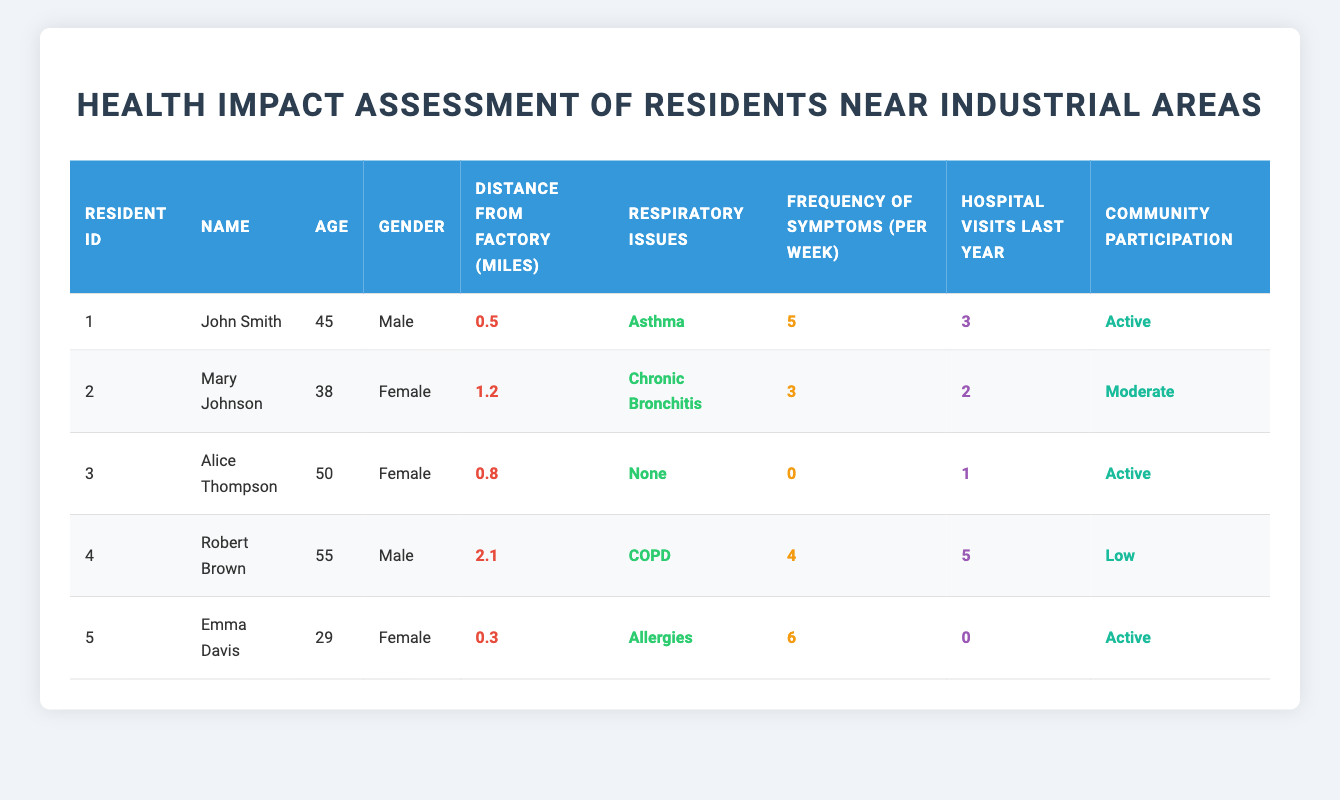What is the respiratory issue reported by John Smith? John Smith's respiratory issue is listed directly in the table under his name, which shows he has asthma.
Answer: Asthma How many hospital visits did Robert Brown have last year? The table states that Robert Brown had 5 hospital visits last year, as shown in the "Hospital Visits Last Year" column.
Answer: 5 How many residents have respiratory issues classified as "None"? The table shows Alice Thompson has "None" listed under respiratory issues, making the count 1.
Answer: 1 What is the average frequency of symptoms among residents with respiratory issues? The frequency of symptoms is as follows: John Smith (5), Mary Johnson (3), Robert Brown (4), and Emma Davis (6). Adding these gives 5 + 3 + 4 + 6 = 18. There are 4 residents with respiratory issues, so the average is 18 / 4 = 4.5.
Answer: 4.5 Is there any resident who had no hospital visits last year? Examining the "Hospital Visits Last Year" column, Emma Davis has 0 visits, indicating a "yes" answer to this question.
Answer: Yes What is the median age of residents with respiratory issues? The ages of residents with respiratory issues (John Smith, Mary Johnson, Robert Brown, Emma Davis) are 45, 38, 55, and 29. Sorting these ages gives us 29, 38, 45, and 55. The median age is the average of the middle two values (38 and 45), which is (38 + 45) / 2 = 41.5.
Answer: 41.5 How many residents live within 1 mile of the factory? By checking the "Distance From Factory" column, Emma Davis (0.3 miles), John Smith (0.5 miles), and Alice Thompson (0.8 miles) all live within 1 mile, making it a total of 3 residents.
Answer: 3 Do all residents with a respiratory issue participate actively in the community? Reviewing the "Community Participation" column reveals that John Smith and Alice Thompson are "Active," but Robert Brown is "Low," indicating that not all residents with respiratory issues are active participants.
Answer: No 